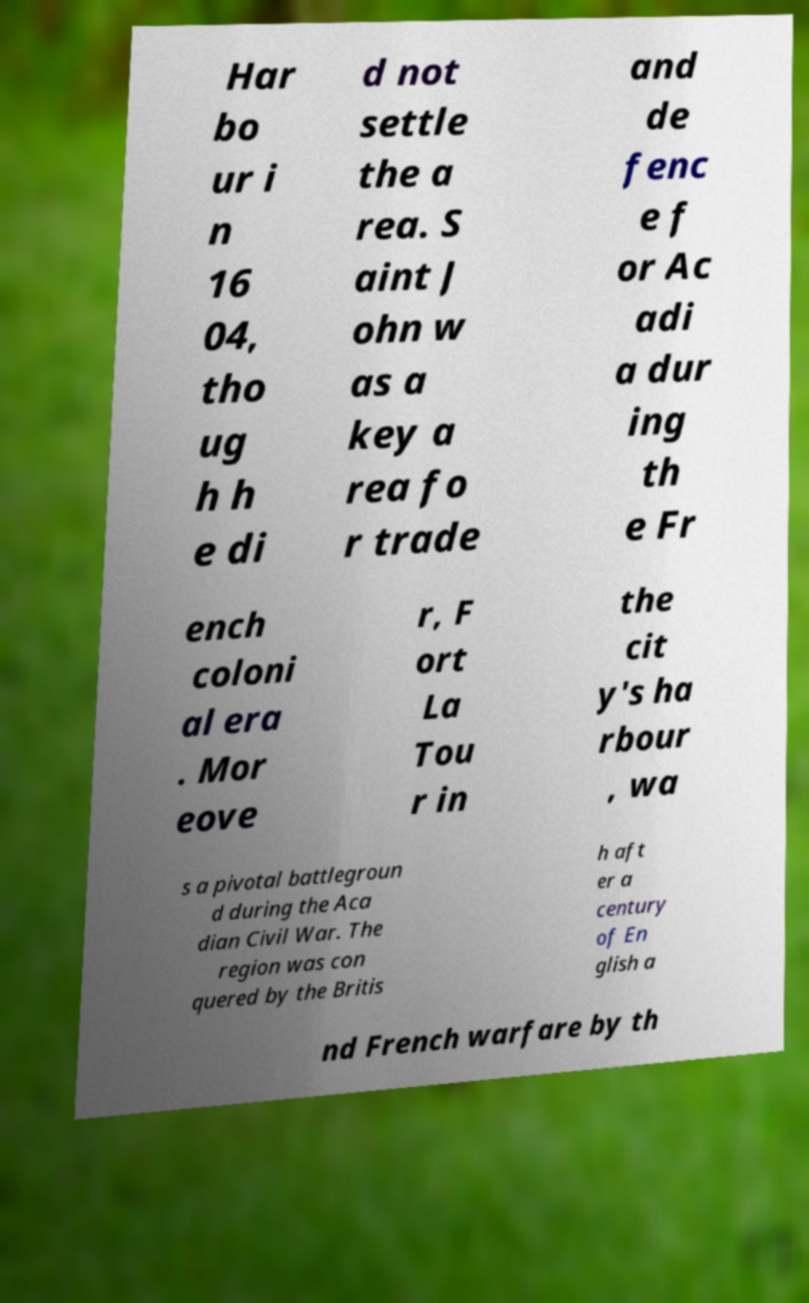Could you extract and type out the text from this image? Har bo ur i n 16 04, tho ug h h e di d not settle the a rea. S aint J ohn w as a key a rea fo r trade and de fenc e f or Ac adi a dur ing th e Fr ench coloni al era . Mor eove r, F ort La Tou r in the cit y's ha rbour , wa s a pivotal battlegroun d during the Aca dian Civil War. The region was con quered by the Britis h aft er a century of En glish a nd French warfare by th 